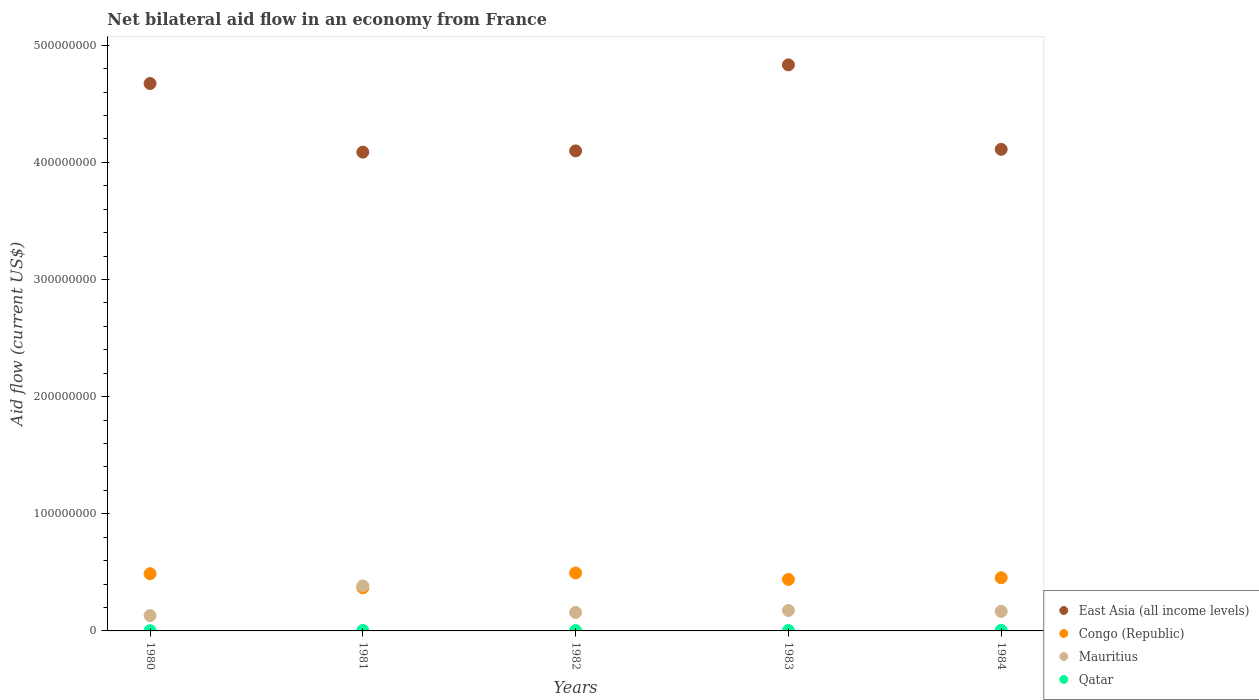How many different coloured dotlines are there?
Provide a short and direct response. 4. Is the number of dotlines equal to the number of legend labels?
Provide a succinct answer. Yes. What is the net bilateral aid flow in Qatar in 1984?
Your answer should be compact. 4.90e+05. Across all years, what is the maximum net bilateral aid flow in East Asia (all income levels)?
Offer a terse response. 4.83e+08. Across all years, what is the minimum net bilateral aid flow in Congo (Republic)?
Offer a very short reply. 3.68e+07. In which year was the net bilateral aid flow in Mauritius maximum?
Give a very brief answer. 1981. What is the total net bilateral aid flow in Congo (Republic) in the graph?
Keep it short and to the point. 2.24e+08. What is the difference between the net bilateral aid flow in Congo (Republic) in 1981 and that in 1982?
Your answer should be compact. -1.27e+07. What is the difference between the net bilateral aid flow in Qatar in 1981 and the net bilateral aid flow in Congo (Republic) in 1980?
Your response must be concise. -4.85e+07. What is the average net bilateral aid flow in Congo (Republic) per year?
Provide a succinct answer. 4.49e+07. In the year 1980, what is the difference between the net bilateral aid flow in East Asia (all income levels) and net bilateral aid flow in Congo (Republic)?
Make the answer very short. 4.18e+08. In how many years, is the net bilateral aid flow in Mauritius greater than 320000000 US$?
Provide a short and direct response. 0. What is the ratio of the net bilateral aid flow in Congo (Republic) in 1983 to that in 1984?
Make the answer very short. 0.97. Is the net bilateral aid flow in Congo (Republic) in 1981 less than that in 1983?
Your answer should be very brief. Yes. Is the difference between the net bilateral aid flow in East Asia (all income levels) in 1981 and 1984 greater than the difference between the net bilateral aid flow in Congo (Republic) in 1981 and 1984?
Your response must be concise. Yes. What is the difference between the highest and the second highest net bilateral aid flow in East Asia (all income levels)?
Your response must be concise. 1.59e+07. What is the difference between the highest and the lowest net bilateral aid flow in Congo (Republic)?
Keep it short and to the point. 1.27e+07. In how many years, is the net bilateral aid flow in East Asia (all income levels) greater than the average net bilateral aid flow in East Asia (all income levels) taken over all years?
Ensure brevity in your answer.  2. Is it the case that in every year, the sum of the net bilateral aid flow in Qatar and net bilateral aid flow in East Asia (all income levels)  is greater than the sum of net bilateral aid flow in Congo (Republic) and net bilateral aid flow in Mauritius?
Provide a succinct answer. Yes. Does the net bilateral aid flow in Qatar monotonically increase over the years?
Ensure brevity in your answer.  No. Is the net bilateral aid flow in Mauritius strictly less than the net bilateral aid flow in Qatar over the years?
Your response must be concise. No. How many dotlines are there?
Ensure brevity in your answer.  4. How many years are there in the graph?
Offer a very short reply. 5. Does the graph contain grids?
Give a very brief answer. No. Where does the legend appear in the graph?
Keep it short and to the point. Bottom right. How many legend labels are there?
Offer a very short reply. 4. What is the title of the graph?
Ensure brevity in your answer.  Net bilateral aid flow in an economy from France. What is the label or title of the X-axis?
Ensure brevity in your answer.  Years. What is the label or title of the Y-axis?
Provide a succinct answer. Aid flow (current US$). What is the Aid flow (current US$) of East Asia (all income levels) in 1980?
Make the answer very short. 4.67e+08. What is the Aid flow (current US$) of Congo (Republic) in 1980?
Offer a very short reply. 4.88e+07. What is the Aid flow (current US$) in Mauritius in 1980?
Ensure brevity in your answer.  1.31e+07. What is the Aid flow (current US$) in Qatar in 1980?
Offer a very short reply. 2.00e+05. What is the Aid flow (current US$) of East Asia (all income levels) in 1981?
Give a very brief answer. 4.09e+08. What is the Aid flow (current US$) of Congo (Republic) in 1981?
Offer a very short reply. 3.68e+07. What is the Aid flow (current US$) in Mauritius in 1981?
Your answer should be compact. 3.84e+07. What is the Aid flow (current US$) in East Asia (all income levels) in 1982?
Provide a succinct answer. 4.10e+08. What is the Aid flow (current US$) of Congo (Republic) in 1982?
Offer a very short reply. 4.95e+07. What is the Aid flow (current US$) of Mauritius in 1982?
Ensure brevity in your answer.  1.58e+07. What is the Aid flow (current US$) in Qatar in 1982?
Your answer should be compact. 2.70e+05. What is the Aid flow (current US$) of East Asia (all income levels) in 1983?
Your answer should be compact. 4.83e+08. What is the Aid flow (current US$) in Congo (Republic) in 1983?
Provide a succinct answer. 4.40e+07. What is the Aid flow (current US$) in Mauritius in 1983?
Your answer should be very brief. 1.74e+07. What is the Aid flow (current US$) in Qatar in 1983?
Give a very brief answer. 4.00e+05. What is the Aid flow (current US$) in East Asia (all income levels) in 1984?
Your answer should be compact. 4.11e+08. What is the Aid flow (current US$) of Congo (Republic) in 1984?
Your answer should be very brief. 4.54e+07. What is the Aid flow (current US$) in Mauritius in 1984?
Offer a very short reply. 1.67e+07. Across all years, what is the maximum Aid flow (current US$) of East Asia (all income levels)?
Offer a very short reply. 4.83e+08. Across all years, what is the maximum Aid flow (current US$) of Congo (Republic)?
Provide a short and direct response. 4.95e+07. Across all years, what is the maximum Aid flow (current US$) in Mauritius?
Your answer should be compact. 3.84e+07. Across all years, what is the minimum Aid flow (current US$) in East Asia (all income levels)?
Keep it short and to the point. 4.09e+08. Across all years, what is the minimum Aid flow (current US$) of Congo (Republic)?
Give a very brief answer. 3.68e+07. Across all years, what is the minimum Aid flow (current US$) in Mauritius?
Make the answer very short. 1.31e+07. Across all years, what is the minimum Aid flow (current US$) in Qatar?
Provide a succinct answer. 2.00e+05. What is the total Aid flow (current US$) in East Asia (all income levels) in the graph?
Keep it short and to the point. 2.18e+09. What is the total Aid flow (current US$) in Congo (Republic) in the graph?
Offer a very short reply. 2.24e+08. What is the total Aid flow (current US$) in Mauritius in the graph?
Provide a succinct answer. 1.01e+08. What is the total Aid flow (current US$) in Qatar in the graph?
Make the answer very short. 1.70e+06. What is the difference between the Aid flow (current US$) of East Asia (all income levels) in 1980 and that in 1981?
Provide a succinct answer. 5.86e+07. What is the difference between the Aid flow (current US$) in Congo (Republic) in 1980 and that in 1981?
Offer a terse response. 1.21e+07. What is the difference between the Aid flow (current US$) of Mauritius in 1980 and that in 1981?
Provide a succinct answer. -2.53e+07. What is the difference between the Aid flow (current US$) of Qatar in 1980 and that in 1981?
Your answer should be very brief. -1.40e+05. What is the difference between the Aid flow (current US$) of East Asia (all income levels) in 1980 and that in 1982?
Your answer should be compact. 5.75e+07. What is the difference between the Aid flow (current US$) of Congo (Republic) in 1980 and that in 1982?
Give a very brief answer. -6.20e+05. What is the difference between the Aid flow (current US$) of Mauritius in 1980 and that in 1982?
Keep it short and to the point. -2.67e+06. What is the difference between the Aid flow (current US$) in East Asia (all income levels) in 1980 and that in 1983?
Provide a short and direct response. -1.59e+07. What is the difference between the Aid flow (current US$) of Congo (Republic) in 1980 and that in 1983?
Your answer should be compact. 4.89e+06. What is the difference between the Aid flow (current US$) in Mauritius in 1980 and that in 1983?
Make the answer very short. -4.33e+06. What is the difference between the Aid flow (current US$) in Qatar in 1980 and that in 1983?
Your answer should be compact. -2.00e+05. What is the difference between the Aid flow (current US$) in East Asia (all income levels) in 1980 and that in 1984?
Offer a terse response. 5.62e+07. What is the difference between the Aid flow (current US$) of Congo (Republic) in 1980 and that in 1984?
Provide a succinct answer. 3.46e+06. What is the difference between the Aid flow (current US$) in Mauritius in 1980 and that in 1984?
Offer a terse response. -3.62e+06. What is the difference between the Aid flow (current US$) of Qatar in 1980 and that in 1984?
Give a very brief answer. -2.90e+05. What is the difference between the Aid flow (current US$) of East Asia (all income levels) in 1981 and that in 1982?
Keep it short and to the point. -1.07e+06. What is the difference between the Aid flow (current US$) of Congo (Republic) in 1981 and that in 1982?
Offer a terse response. -1.27e+07. What is the difference between the Aid flow (current US$) in Mauritius in 1981 and that in 1982?
Your answer should be compact. 2.26e+07. What is the difference between the Aid flow (current US$) in East Asia (all income levels) in 1981 and that in 1983?
Keep it short and to the point. -7.45e+07. What is the difference between the Aid flow (current US$) in Congo (Republic) in 1981 and that in 1983?
Give a very brief answer. -7.20e+06. What is the difference between the Aid flow (current US$) of Mauritius in 1981 and that in 1983?
Ensure brevity in your answer.  2.10e+07. What is the difference between the Aid flow (current US$) in East Asia (all income levels) in 1981 and that in 1984?
Make the answer very short. -2.41e+06. What is the difference between the Aid flow (current US$) in Congo (Republic) in 1981 and that in 1984?
Offer a terse response. -8.63e+06. What is the difference between the Aid flow (current US$) in Mauritius in 1981 and that in 1984?
Provide a short and direct response. 2.17e+07. What is the difference between the Aid flow (current US$) of East Asia (all income levels) in 1982 and that in 1983?
Your answer should be very brief. -7.34e+07. What is the difference between the Aid flow (current US$) in Congo (Republic) in 1982 and that in 1983?
Keep it short and to the point. 5.51e+06. What is the difference between the Aid flow (current US$) of Mauritius in 1982 and that in 1983?
Offer a terse response. -1.66e+06. What is the difference between the Aid flow (current US$) of East Asia (all income levels) in 1982 and that in 1984?
Offer a very short reply. -1.34e+06. What is the difference between the Aid flow (current US$) of Congo (Republic) in 1982 and that in 1984?
Your answer should be compact. 4.08e+06. What is the difference between the Aid flow (current US$) in Mauritius in 1982 and that in 1984?
Your answer should be very brief. -9.50e+05. What is the difference between the Aid flow (current US$) in East Asia (all income levels) in 1983 and that in 1984?
Give a very brief answer. 7.21e+07. What is the difference between the Aid flow (current US$) of Congo (Republic) in 1983 and that in 1984?
Your answer should be compact. -1.43e+06. What is the difference between the Aid flow (current US$) of Mauritius in 1983 and that in 1984?
Keep it short and to the point. 7.10e+05. What is the difference between the Aid flow (current US$) of East Asia (all income levels) in 1980 and the Aid flow (current US$) of Congo (Republic) in 1981?
Your answer should be very brief. 4.31e+08. What is the difference between the Aid flow (current US$) of East Asia (all income levels) in 1980 and the Aid flow (current US$) of Mauritius in 1981?
Make the answer very short. 4.29e+08. What is the difference between the Aid flow (current US$) of East Asia (all income levels) in 1980 and the Aid flow (current US$) of Qatar in 1981?
Keep it short and to the point. 4.67e+08. What is the difference between the Aid flow (current US$) in Congo (Republic) in 1980 and the Aid flow (current US$) in Mauritius in 1981?
Your answer should be compact. 1.04e+07. What is the difference between the Aid flow (current US$) of Congo (Republic) in 1980 and the Aid flow (current US$) of Qatar in 1981?
Offer a very short reply. 4.85e+07. What is the difference between the Aid flow (current US$) in Mauritius in 1980 and the Aid flow (current US$) in Qatar in 1981?
Ensure brevity in your answer.  1.28e+07. What is the difference between the Aid flow (current US$) of East Asia (all income levels) in 1980 and the Aid flow (current US$) of Congo (Republic) in 1982?
Give a very brief answer. 4.18e+08. What is the difference between the Aid flow (current US$) of East Asia (all income levels) in 1980 and the Aid flow (current US$) of Mauritius in 1982?
Keep it short and to the point. 4.52e+08. What is the difference between the Aid flow (current US$) of East Asia (all income levels) in 1980 and the Aid flow (current US$) of Qatar in 1982?
Offer a very short reply. 4.67e+08. What is the difference between the Aid flow (current US$) in Congo (Republic) in 1980 and the Aid flow (current US$) in Mauritius in 1982?
Your answer should be compact. 3.31e+07. What is the difference between the Aid flow (current US$) in Congo (Republic) in 1980 and the Aid flow (current US$) in Qatar in 1982?
Your response must be concise. 4.86e+07. What is the difference between the Aid flow (current US$) of Mauritius in 1980 and the Aid flow (current US$) of Qatar in 1982?
Provide a succinct answer. 1.28e+07. What is the difference between the Aid flow (current US$) in East Asia (all income levels) in 1980 and the Aid flow (current US$) in Congo (Republic) in 1983?
Provide a short and direct response. 4.23e+08. What is the difference between the Aid flow (current US$) in East Asia (all income levels) in 1980 and the Aid flow (current US$) in Mauritius in 1983?
Your answer should be very brief. 4.50e+08. What is the difference between the Aid flow (current US$) in East Asia (all income levels) in 1980 and the Aid flow (current US$) in Qatar in 1983?
Give a very brief answer. 4.67e+08. What is the difference between the Aid flow (current US$) in Congo (Republic) in 1980 and the Aid flow (current US$) in Mauritius in 1983?
Give a very brief answer. 3.14e+07. What is the difference between the Aid flow (current US$) of Congo (Republic) in 1980 and the Aid flow (current US$) of Qatar in 1983?
Provide a succinct answer. 4.84e+07. What is the difference between the Aid flow (current US$) of Mauritius in 1980 and the Aid flow (current US$) of Qatar in 1983?
Provide a succinct answer. 1.27e+07. What is the difference between the Aid flow (current US$) in East Asia (all income levels) in 1980 and the Aid flow (current US$) in Congo (Republic) in 1984?
Give a very brief answer. 4.22e+08. What is the difference between the Aid flow (current US$) of East Asia (all income levels) in 1980 and the Aid flow (current US$) of Mauritius in 1984?
Keep it short and to the point. 4.51e+08. What is the difference between the Aid flow (current US$) of East Asia (all income levels) in 1980 and the Aid flow (current US$) of Qatar in 1984?
Offer a very short reply. 4.67e+08. What is the difference between the Aid flow (current US$) of Congo (Republic) in 1980 and the Aid flow (current US$) of Mauritius in 1984?
Provide a short and direct response. 3.21e+07. What is the difference between the Aid flow (current US$) in Congo (Republic) in 1980 and the Aid flow (current US$) in Qatar in 1984?
Make the answer very short. 4.84e+07. What is the difference between the Aid flow (current US$) in Mauritius in 1980 and the Aid flow (current US$) in Qatar in 1984?
Keep it short and to the point. 1.26e+07. What is the difference between the Aid flow (current US$) of East Asia (all income levels) in 1981 and the Aid flow (current US$) of Congo (Republic) in 1982?
Your answer should be very brief. 3.59e+08. What is the difference between the Aid flow (current US$) of East Asia (all income levels) in 1981 and the Aid flow (current US$) of Mauritius in 1982?
Your answer should be very brief. 3.93e+08. What is the difference between the Aid flow (current US$) of East Asia (all income levels) in 1981 and the Aid flow (current US$) of Qatar in 1982?
Your answer should be compact. 4.08e+08. What is the difference between the Aid flow (current US$) of Congo (Republic) in 1981 and the Aid flow (current US$) of Mauritius in 1982?
Keep it short and to the point. 2.10e+07. What is the difference between the Aid flow (current US$) in Congo (Republic) in 1981 and the Aid flow (current US$) in Qatar in 1982?
Your response must be concise. 3.65e+07. What is the difference between the Aid flow (current US$) of Mauritius in 1981 and the Aid flow (current US$) of Qatar in 1982?
Provide a succinct answer. 3.81e+07. What is the difference between the Aid flow (current US$) in East Asia (all income levels) in 1981 and the Aid flow (current US$) in Congo (Republic) in 1983?
Your response must be concise. 3.65e+08. What is the difference between the Aid flow (current US$) in East Asia (all income levels) in 1981 and the Aid flow (current US$) in Mauritius in 1983?
Provide a succinct answer. 3.91e+08. What is the difference between the Aid flow (current US$) in East Asia (all income levels) in 1981 and the Aid flow (current US$) in Qatar in 1983?
Your response must be concise. 4.08e+08. What is the difference between the Aid flow (current US$) of Congo (Republic) in 1981 and the Aid flow (current US$) of Mauritius in 1983?
Provide a succinct answer. 1.93e+07. What is the difference between the Aid flow (current US$) in Congo (Republic) in 1981 and the Aid flow (current US$) in Qatar in 1983?
Your answer should be compact. 3.64e+07. What is the difference between the Aid flow (current US$) in Mauritius in 1981 and the Aid flow (current US$) in Qatar in 1983?
Your answer should be compact. 3.80e+07. What is the difference between the Aid flow (current US$) of East Asia (all income levels) in 1981 and the Aid flow (current US$) of Congo (Republic) in 1984?
Provide a short and direct response. 3.63e+08. What is the difference between the Aid flow (current US$) in East Asia (all income levels) in 1981 and the Aid flow (current US$) in Mauritius in 1984?
Give a very brief answer. 3.92e+08. What is the difference between the Aid flow (current US$) in East Asia (all income levels) in 1981 and the Aid flow (current US$) in Qatar in 1984?
Your answer should be compact. 4.08e+08. What is the difference between the Aid flow (current US$) of Congo (Republic) in 1981 and the Aid flow (current US$) of Mauritius in 1984?
Keep it short and to the point. 2.00e+07. What is the difference between the Aid flow (current US$) in Congo (Republic) in 1981 and the Aid flow (current US$) in Qatar in 1984?
Make the answer very short. 3.63e+07. What is the difference between the Aid flow (current US$) of Mauritius in 1981 and the Aid flow (current US$) of Qatar in 1984?
Offer a terse response. 3.79e+07. What is the difference between the Aid flow (current US$) in East Asia (all income levels) in 1982 and the Aid flow (current US$) in Congo (Republic) in 1983?
Your answer should be very brief. 3.66e+08. What is the difference between the Aid flow (current US$) in East Asia (all income levels) in 1982 and the Aid flow (current US$) in Mauritius in 1983?
Offer a terse response. 3.92e+08. What is the difference between the Aid flow (current US$) of East Asia (all income levels) in 1982 and the Aid flow (current US$) of Qatar in 1983?
Provide a succinct answer. 4.09e+08. What is the difference between the Aid flow (current US$) of Congo (Republic) in 1982 and the Aid flow (current US$) of Mauritius in 1983?
Give a very brief answer. 3.20e+07. What is the difference between the Aid flow (current US$) of Congo (Republic) in 1982 and the Aid flow (current US$) of Qatar in 1983?
Offer a terse response. 4.91e+07. What is the difference between the Aid flow (current US$) of Mauritius in 1982 and the Aid flow (current US$) of Qatar in 1983?
Your answer should be very brief. 1.54e+07. What is the difference between the Aid flow (current US$) of East Asia (all income levels) in 1982 and the Aid flow (current US$) of Congo (Republic) in 1984?
Keep it short and to the point. 3.64e+08. What is the difference between the Aid flow (current US$) of East Asia (all income levels) in 1982 and the Aid flow (current US$) of Mauritius in 1984?
Offer a very short reply. 3.93e+08. What is the difference between the Aid flow (current US$) of East Asia (all income levels) in 1982 and the Aid flow (current US$) of Qatar in 1984?
Your response must be concise. 4.09e+08. What is the difference between the Aid flow (current US$) in Congo (Republic) in 1982 and the Aid flow (current US$) in Mauritius in 1984?
Your answer should be compact. 3.28e+07. What is the difference between the Aid flow (current US$) in Congo (Republic) in 1982 and the Aid flow (current US$) in Qatar in 1984?
Offer a terse response. 4.90e+07. What is the difference between the Aid flow (current US$) in Mauritius in 1982 and the Aid flow (current US$) in Qatar in 1984?
Make the answer very short. 1.53e+07. What is the difference between the Aid flow (current US$) in East Asia (all income levels) in 1983 and the Aid flow (current US$) in Congo (Republic) in 1984?
Give a very brief answer. 4.38e+08. What is the difference between the Aid flow (current US$) in East Asia (all income levels) in 1983 and the Aid flow (current US$) in Mauritius in 1984?
Your answer should be compact. 4.66e+08. What is the difference between the Aid flow (current US$) of East Asia (all income levels) in 1983 and the Aid flow (current US$) of Qatar in 1984?
Offer a terse response. 4.83e+08. What is the difference between the Aid flow (current US$) of Congo (Republic) in 1983 and the Aid flow (current US$) of Mauritius in 1984?
Offer a very short reply. 2.72e+07. What is the difference between the Aid flow (current US$) in Congo (Republic) in 1983 and the Aid flow (current US$) in Qatar in 1984?
Make the answer very short. 4.35e+07. What is the difference between the Aid flow (current US$) of Mauritius in 1983 and the Aid flow (current US$) of Qatar in 1984?
Ensure brevity in your answer.  1.69e+07. What is the average Aid flow (current US$) of East Asia (all income levels) per year?
Your answer should be compact. 4.36e+08. What is the average Aid flow (current US$) in Congo (Republic) per year?
Give a very brief answer. 4.49e+07. What is the average Aid flow (current US$) in Mauritius per year?
Give a very brief answer. 2.03e+07. What is the average Aid flow (current US$) of Qatar per year?
Your answer should be very brief. 3.40e+05. In the year 1980, what is the difference between the Aid flow (current US$) of East Asia (all income levels) and Aid flow (current US$) of Congo (Republic)?
Ensure brevity in your answer.  4.18e+08. In the year 1980, what is the difference between the Aid flow (current US$) of East Asia (all income levels) and Aid flow (current US$) of Mauritius?
Ensure brevity in your answer.  4.54e+08. In the year 1980, what is the difference between the Aid flow (current US$) in East Asia (all income levels) and Aid flow (current US$) in Qatar?
Provide a succinct answer. 4.67e+08. In the year 1980, what is the difference between the Aid flow (current US$) of Congo (Republic) and Aid flow (current US$) of Mauritius?
Ensure brevity in your answer.  3.58e+07. In the year 1980, what is the difference between the Aid flow (current US$) of Congo (Republic) and Aid flow (current US$) of Qatar?
Offer a terse response. 4.86e+07. In the year 1980, what is the difference between the Aid flow (current US$) in Mauritius and Aid flow (current US$) in Qatar?
Keep it short and to the point. 1.29e+07. In the year 1981, what is the difference between the Aid flow (current US$) in East Asia (all income levels) and Aid flow (current US$) in Congo (Republic)?
Your answer should be compact. 3.72e+08. In the year 1981, what is the difference between the Aid flow (current US$) in East Asia (all income levels) and Aid flow (current US$) in Mauritius?
Provide a short and direct response. 3.70e+08. In the year 1981, what is the difference between the Aid flow (current US$) of East Asia (all income levels) and Aid flow (current US$) of Qatar?
Provide a succinct answer. 4.08e+08. In the year 1981, what is the difference between the Aid flow (current US$) of Congo (Republic) and Aid flow (current US$) of Mauritius?
Provide a short and direct response. -1.65e+06. In the year 1981, what is the difference between the Aid flow (current US$) of Congo (Republic) and Aid flow (current US$) of Qatar?
Your response must be concise. 3.64e+07. In the year 1981, what is the difference between the Aid flow (current US$) of Mauritius and Aid flow (current US$) of Qatar?
Make the answer very short. 3.81e+07. In the year 1982, what is the difference between the Aid flow (current US$) in East Asia (all income levels) and Aid flow (current US$) in Congo (Republic)?
Make the answer very short. 3.60e+08. In the year 1982, what is the difference between the Aid flow (current US$) of East Asia (all income levels) and Aid flow (current US$) of Mauritius?
Your response must be concise. 3.94e+08. In the year 1982, what is the difference between the Aid flow (current US$) in East Asia (all income levels) and Aid flow (current US$) in Qatar?
Offer a very short reply. 4.09e+08. In the year 1982, what is the difference between the Aid flow (current US$) in Congo (Republic) and Aid flow (current US$) in Mauritius?
Make the answer very short. 3.37e+07. In the year 1982, what is the difference between the Aid flow (current US$) of Congo (Republic) and Aid flow (current US$) of Qatar?
Keep it short and to the point. 4.92e+07. In the year 1982, what is the difference between the Aid flow (current US$) in Mauritius and Aid flow (current US$) in Qatar?
Provide a short and direct response. 1.55e+07. In the year 1983, what is the difference between the Aid flow (current US$) in East Asia (all income levels) and Aid flow (current US$) in Congo (Republic)?
Make the answer very short. 4.39e+08. In the year 1983, what is the difference between the Aid flow (current US$) of East Asia (all income levels) and Aid flow (current US$) of Mauritius?
Offer a very short reply. 4.66e+08. In the year 1983, what is the difference between the Aid flow (current US$) in East Asia (all income levels) and Aid flow (current US$) in Qatar?
Ensure brevity in your answer.  4.83e+08. In the year 1983, what is the difference between the Aid flow (current US$) in Congo (Republic) and Aid flow (current US$) in Mauritius?
Offer a terse response. 2.65e+07. In the year 1983, what is the difference between the Aid flow (current US$) of Congo (Republic) and Aid flow (current US$) of Qatar?
Provide a short and direct response. 4.36e+07. In the year 1983, what is the difference between the Aid flow (current US$) of Mauritius and Aid flow (current US$) of Qatar?
Keep it short and to the point. 1.70e+07. In the year 1984, what is the difference between the Aid flow (current US$) of East Asia (all income levels) and Aid flow (current US$) of Congo (Republic)?
Give a very brief answer. 3.66e+08. In the year 1984, what is the difference between the Aid flow (current US$) in East Asia (all income levels) and Aid flow (current US$) in Mauritius?
Provide a short and direct response. 3.94e+08. In the year 1984, what is the difference between the Aid flow (current US$) of East Asia (all income levels) and Aid flow (current US$) of Qatar?
Offer a very short reply. 4.11e+08. In the year 1984, what is the difference between the Aid flow (current US$) of Congo (Republic) and Aid flow (current US$) of Mauritius?
Give a very brief answer. 2.87e+07. In the year 1984, what is the difference between the Aid flow (current US$) in Congo (Republic) and Aid flow (current US$) in Qatar?
Offer a terse response. 4.49e+07. In the year 1984, what is the difference between the Aid flow (current US$) in Mauritius and Aid flow (current US$) in Qatar?
Make the answer very short. 1.62e+07. What is the ratio of the Aid flow (current US$) of East Asia (all income levels) in 1980 to that in 1981?
Ensure brevity in your answer.  1.14. What is the ratio of the Aid flow (current US$) in Congo (Republic) in 1980 to that in 1981?
Offer a terse response. 1.33. What is the ratio of the Aid flow (current US$) in Mauritius in 1980 to that in 1981?
Your answer should be compact. 0.34. What is the ratio of the Aid flow (current US$) in Qatar in 1980 to that in 1981?
Keep it short and to the point. 0.59. What is the ratio of the Aid flow (current US$) of East Asia (all income levels) in 1980 to that in 1982?
Your answer should be very brief. 1.14. What is the ratio of the Aid flow (current US$) in Congo (Republic) in 1980 to that in 1982?
Your answer should be compact. 0.99. What is the ratio of the Aid flow (current US$) in Mauritius in 1980 to that in 1982?
Give a very brief answer. 0.83. What is the ratio of the Aid flow (current US$) of Qatar in 1980 to that in 1982?
Offer a very short reply. 0.74. What is the ratio of the Aid flow (current US$) in East Asia (all income levels) in 1980 to that in 1983?
Offer a very short reply. 0.97. What is the ratio of the Aid flow (current US$) of Congo (Republic) in 1980 to that in 1983?
Give a very brief answer. 1.11. What is the ratio of the Aid flow (current US$) of Mauritius in 1980 to that in 1983?
Make the answer very short. 0.75. What is the ratio of the Aid flow (current US$) in Qatar in 1980 to that in 1983?
Keep it short and to the point. 0.5. What is the ratio of the Aid flow (current US$) in East Asia (all income levels) in 1980 to that in 1984?
Give a very brief answer. 1.14. What is the ratio of the Aid flow (current US$) of Congo (Republic) in 1980 to that in 1984?
Offer a very short reply. 1.08. What is the ratio of the Aid flow (current US$) of Mauritius in 1980 to that in 1984?
Ensure brevity in your answer.  0.78. What is the ratio of the Aid flow (current US$) of Qatar in 1980 to that in 1984?
Give a very brief answer. 0.41. What is the ratio of the Aid flow (current US$) in East Asia (all income levels) in 1981 to that in 1982?
Your response must be concise. 1. What is the ratio of the Aid flow (current US$) of Congo (Republic) in 1981 to that in 1982?
Provide a short and direct response. 0.74. What is the ratio of the Aid flow (current US$) of Mauritius in 1981 to that in 1982?
Provide a succinct answer. 2.44. What is the ratio of the Aid flow (current US$) of Qatar in 1981 to that in 1982?
Ensure brevity in your answer.  1.26. What is the ratio of the Aid flow (current US$) of East Asia (all income levels) in 1981 to that in 1983?
Ensure brevity in your answer.  0.85. What is the ratio of the Aid flow (current US$) in Congo (Republic) in 1981 to that in 1983?
Your answer should be very brief. 0.84. What is the ratio of the Aid flow (current US$) of Mauritius in 1981 to that in 1983?
Keep it short and to the point. 2.2. What is the ratio of the Aid flow (current US$) in Congo (Republic) in 1981 to that in 1984?
Your answer should be compact. 0.81. What is the ratio of the Aid flow (current US$) in Mauritius in 1981 to that in 1984?
Your response must be concise. 2.3. What is the ratio of the Aid flow (current US$) in Qatar in 1981 to that in 1984?
Give a very brief answer. 0.69. What is the ratio of the Aid flow (current US$) in East Asia (all income levels) in 1982 to that in 1983?
Offer a very short reply. 0.85. What is the ratio of the Aid flow (current US$) in Congo (Republic) in 1982 to that in 1983?
Make the answer very short. 1.13. What is the ratio of the Aid flow (current US$) of Mauritius in 1982 to that in 1983?
Ensure brevity in your answer.  0.9. What is the ratio of the Aid flow (current US$) of Qatar in 1982 to that in 1983?
Keep it short and to the point. 0.68. What is the ratio of the Aid flow (current US$) in East Asia (all income levels) in 1982 to that in 1984?
Give a very brief answer. 1. What is the ratio of the Aid flow (current US$) of Congo (Republic) in 1982 to that in 1984?
Make the answer very short. 1.09. What is the ratio of the Aid flow (current US$) of Mauritius in 1982 to that in 1984?
Provide a short and direct response. 0.94. What is the ratio of the Aid flow (current US$) in Qatar in 1982 to that in 1984?
Provide a short and direct response. 0.55. What is the ratio of the Aid flow (current US$) in East Asia (all income levels) in 1983 to that in 1984?
Your response must be concise. 1.18. What is the ratio of the Aid flow (current US$) of Congo (Republic) in 1983 to that in 1984?
Offer a very short reply. 0.97. What is the ratio of the Aid flow (current US$) in Mauritius in 1983 to that in 1984?
Offer a terse response. 1.04. What is the ratio of the Aid flow (current US$) in Qatar in 1983 to that in 1984?
Your response must be concise. 0.82. What is the difference between the highest and the second highest Aid flow (current US$) in East Asia (all income levels)?
Provide a succinct answer. 1.59e+07. What is the difference between the highest and the second highest Aid flow (current US$) in Congo (Republic)?
Offer a terse response. 6.20e+05. What is the difference between the highest and the second highest Aid flow (current US$) of Mauritius?
Give a very brief answer. 2.10e+07. What is the difference between the highest and the lowest Aid flow (current US$) in East Asia (all income levels)?
Make the answer very short. 7.45e+07. What is the difference between the highest and the lowest Aid flow (current US$) in Congo (Republic)?
Give a very brief answer. 1.27e+07. What is the difference between the highest and the lowest Aid flow (current US$) in Mauritius?
Offer a terse response. 2.53e+07. What is the difference between the highest and the lowest Aid flow (current US$) of Qatar?
Make the answer very short. 2.90e+05. 